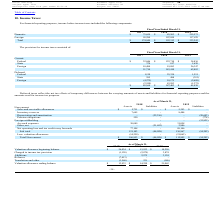According to Avx Corporation's financial document, What is the company's total income before income taxes for the fiscal year ended March 31, 2019? According to the financial document, 333,243. The relevant text states: "Total $ 174,949 $ 192,313 $ 333,243..." Also, What is the company's total income before income taxes for the fiscal year ended March 31, 2018? According to the financial document, 192,313. The relevant text states: "Total $ 174,949 $ 192,313 $ 333,243..." Also, What is the company's total income before income taxes for the fiscal year ended March 31, 2017? According to the financial document, 174,949. The relevant text states: "Total $ 174,949 $ 192,313 $ 333,243..." Also, can you calculate: What is the proportion of the domestic income as a percentage of the total income in 2019? Based on the calculation: 215,573/333,243 , the result is 64.69 (percentage). This is based on the information: "Total $ 174,949 $ 192,313 $ 333,243 Domestic $ 75,659 $ 85,263 $ 215,573..." The key data points involved are: 215,573, 333,243. Also, can you calculate: What is the change in total income before income taxes between 2017 and 2018? Based on the calculation: 192,313 - 174,949 , the result is 17364. This is based on the information: "Total $ 174,949 $ 192,313 $ 333,243 Total $ 174,949 $ 192,313 $ 333,243..." The key data points involved are: 174,949, 192,313. Also, can you calculate: What is the percentage change in total income between 2018 and 2019? To answer this question, I need to perform calculations using the financial data. The calculation is: (333,243 - 192,313)/192,313 , which equals 73.28 (percentage). This is based on the information: "Total $ 174,949 $ 192,313 $ 333,243 Total $ 174,949 $ 192,313 $ 333,243..." The key data points involved are: 192,313, 333,243. 